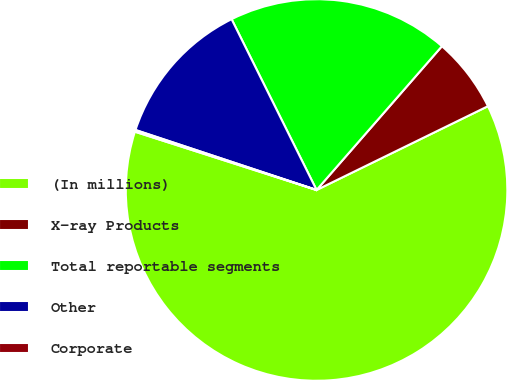<chart> <loc_0><loc_0><loc_500><loc_500><pie_chart><fcel>(In millions)<fcel>X-ray Products<fcel>Total reportable segments<fcel>Other<fcel>Corporate<nl><fcel>62.18%<fcel>6.35%<fcel>18.76%<fcel>12.56%<fcel>0.15%<nl></chart> 